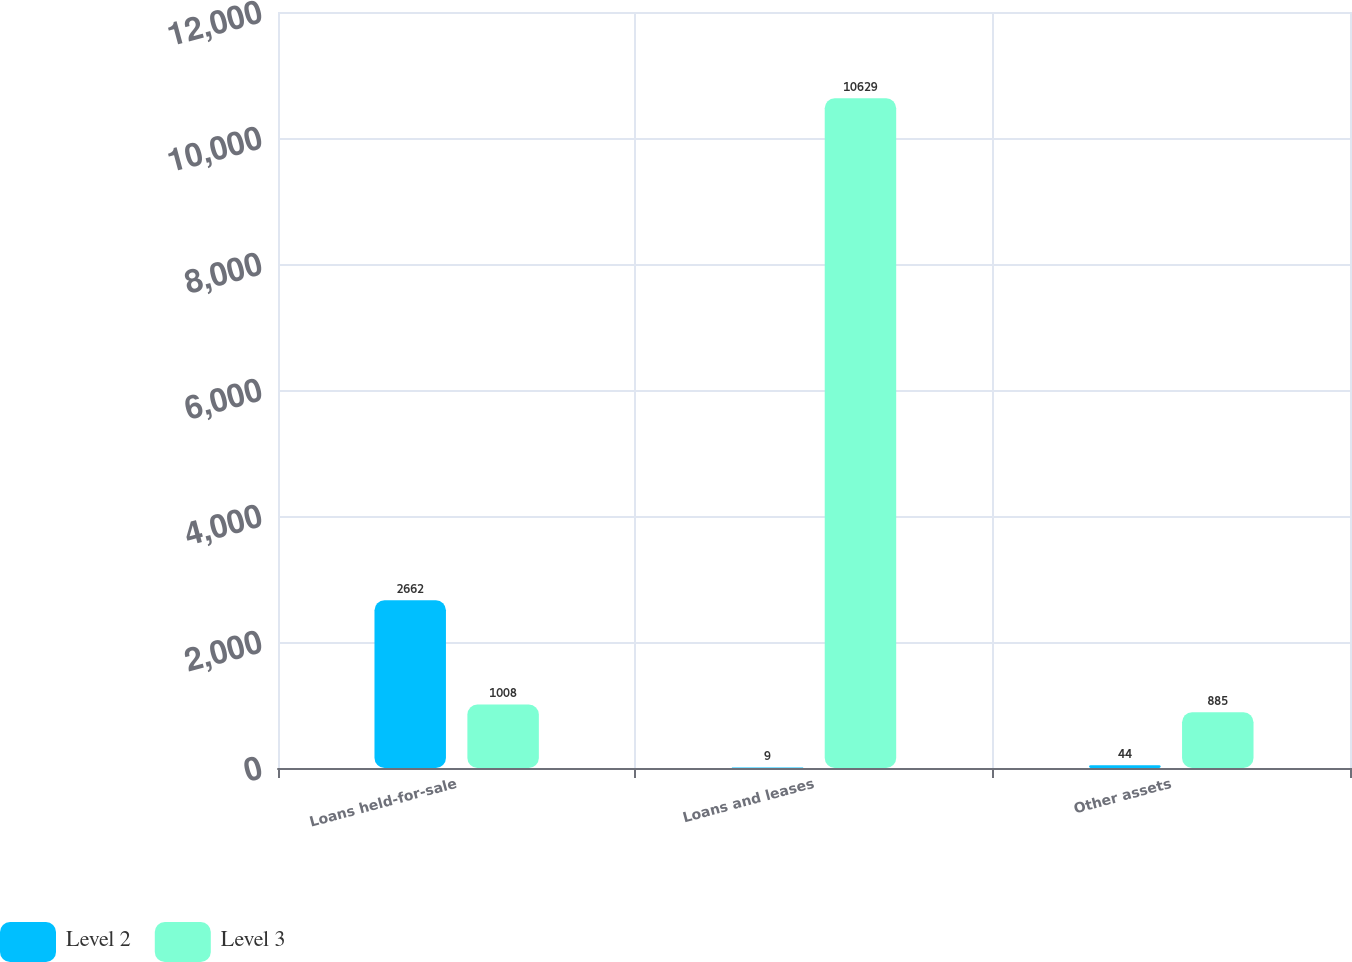Convert chart. <chart><loc_0><loc_0><loc_500><loc_500><stacked_bar_chart><ecel><fcel>Loans held-for-sale<fcel>Loans and leases<fcel>Other assets<nl><fcel>Level 2<fcel>2662<fcel>9<fcel>44<nl><fcel>Level 3<fcel>1008<fcel>10629<fcel>885<nl></chart> 